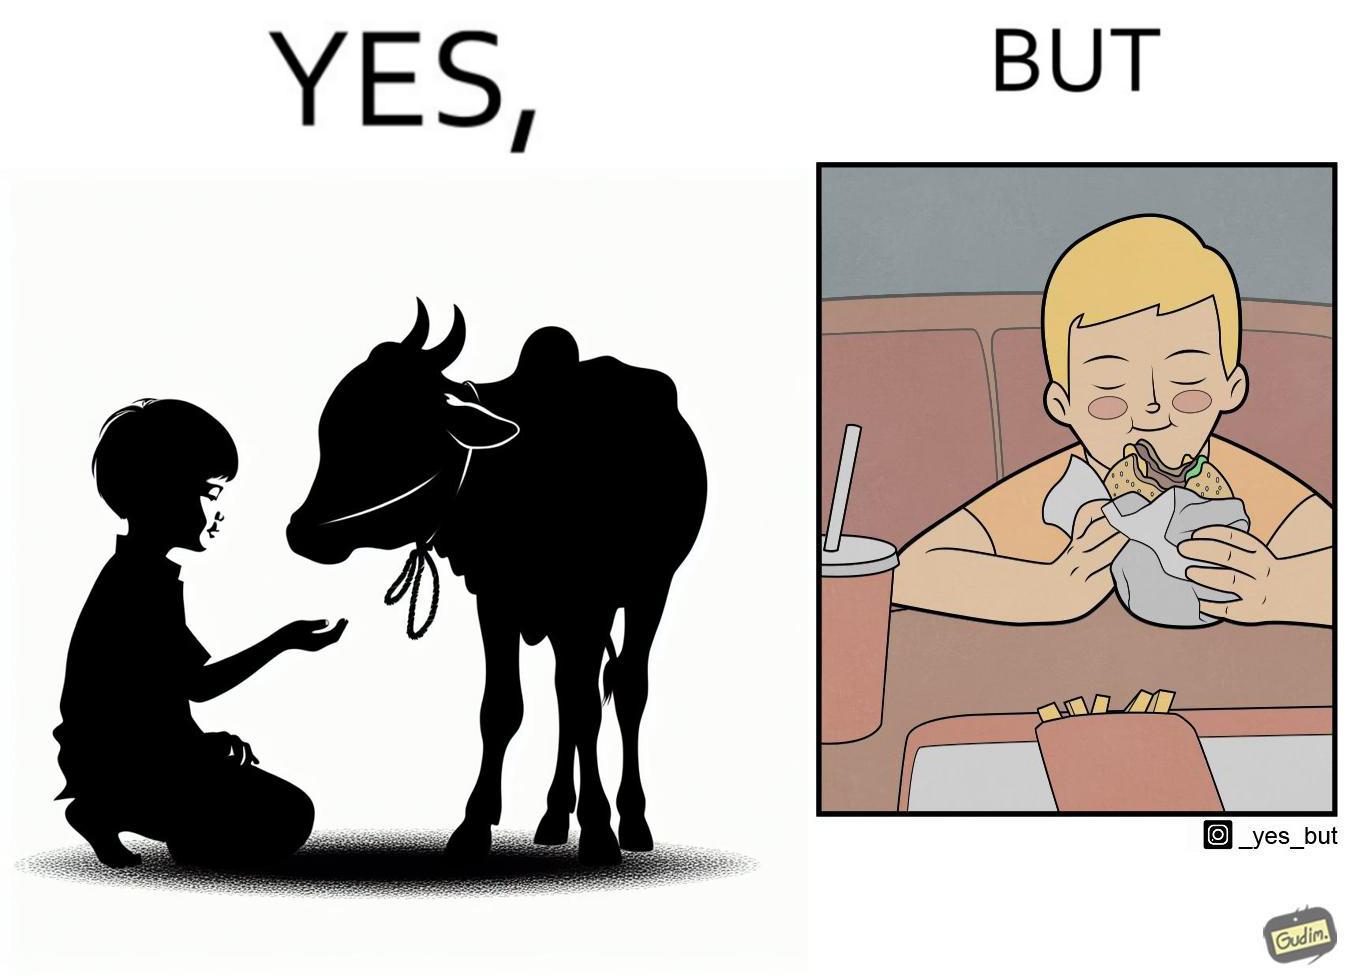What is shown in this image? The irony is that the boy is petting the cow to show that he cares about the animal, but then he also eats hamburgers made from the same cows 